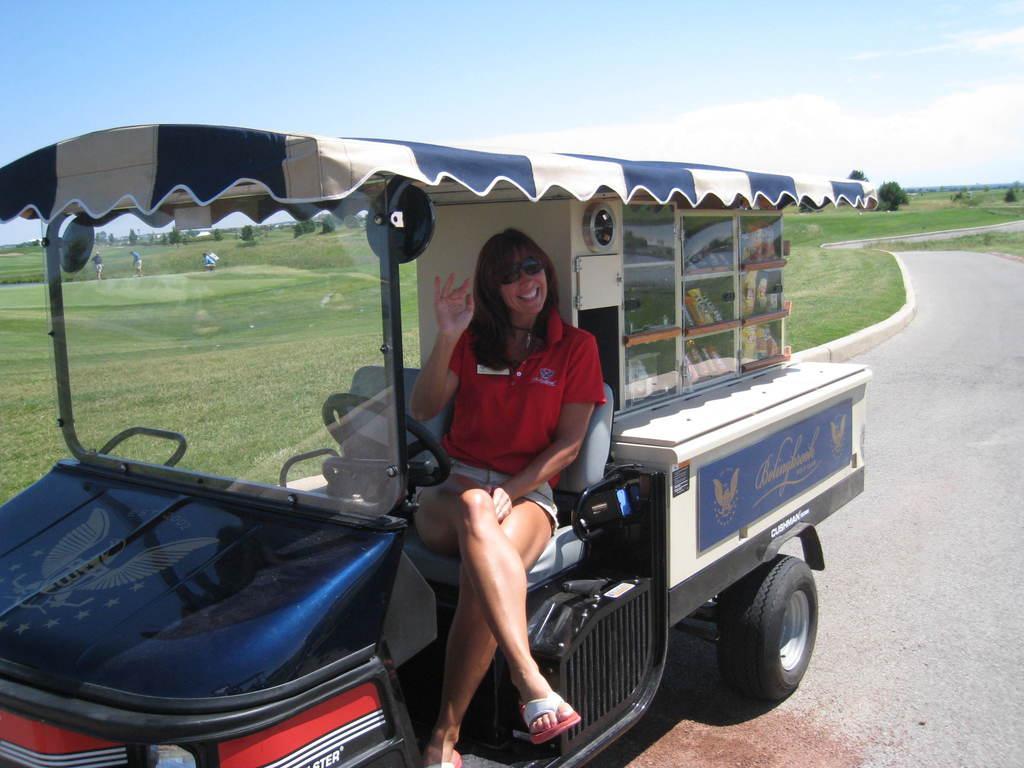In one or two sentences, can you explain what this image depicts? The girl sitting in a truck which is carrying some stuff and there is grass beside her. 